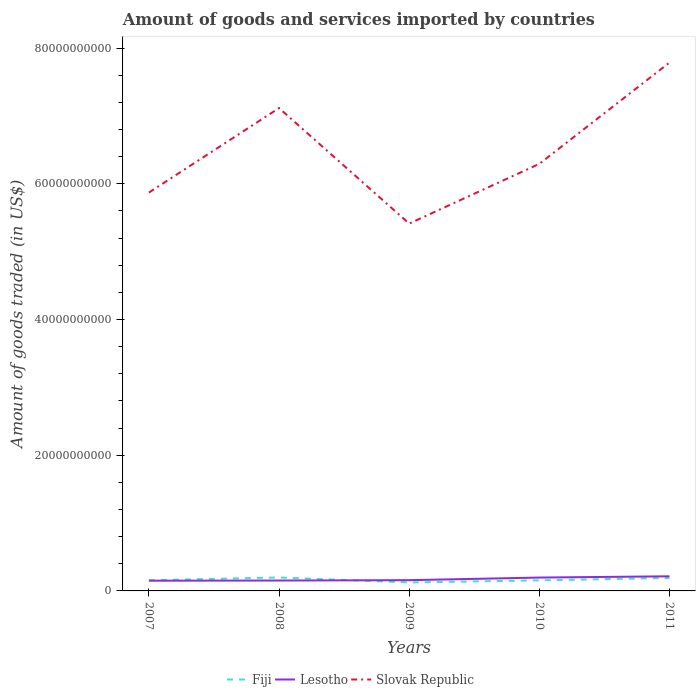How many different coloured lines are there?
Your response must be concise. 3. Does the line corresponding to Lesotho intersect with the line corresponding to Slovak Republic?
Offer a very short reply. No. Across all years, what is the maximum total amount of goods and services imported in Slovak Republic?
Keep it short and to the point. 5.41e+1. In which year was the total amount of goods and services imported in Lesotho maximum?
Provide a succinct answer. 2007. What is the total total amount of goods and services imported in Fiji in the graph?
Keep it short and to the point. 4.24e+08. What is the difference between the highest and the second highest total amount of goods and services imported in Lesotho?
Give a very brief answer. 6.49e+08. What is the difference between the highest and the lowest total amount of goods and services imported in Lesotho?
Provide a succinct answer. 2. Is the total amount of goods and services imported in Lesotho strictly greater than the total amount of goods and services imported in Slovak Republic over the years?
Provide a short and direct response. Yes. Are the values on the major ticks of Y-axis written in scientific E-notation?
Make the answer very short. No. Does the graph contain any zero values?
Your answer should be compact. No. Does the graph contain grids?
Provide a short and direct response. No. How many legend labels are there?
Your response must be concise. 3. How are the legend labels stacked?
Ensure brevity in your answer.  Horizontal. What is the title of the graph?
Give a very brief answer. Amount of goods and services imported by countries. What is the label or title of the Y-axis?
Your answer should be very brief. Amount of goods traded (in US$). What is the Amount of goods traded (in US$) of Fiji in 2007?
Ensure brevity in your answer.  1.58e+09. What is the Amount of goods traded (in US$) of Lesotho in 2007?
Keep it short and to the point. 1.51e+09. What is the Amount of goods traded (in US$) of Slovak Republic in 2007?
Ensure brevity in your answer.  5.87e+1. What is the Amount of goods traded (in US$) of Fiji in 2008?
Offer a terse response. 1.98e+09. What is the Amount of goods traded (in US$) in Lesotho in 2008?
Ensure brevity in your answer.  1.53e+09. What is the Amount of goods traded (in US$) of Slovak Republic in 2008?
Offer a very short reply. 7.12e+1. What is the Amount of goods traded (in US$) in Fiji in 2009?
Give a very brief answer. 1.25e+09. What is the Amount of goods traded (in US$) in Lesotho in 2009?
Make the answer very short. 1.58e+09. What is the Amount of goods traded (in US$) of Slovak Republic in 2009?
Offer a very short reply. 5.41e+1. What is the Amount of goods traded (in US$) of Fiji in 2010?
Provide a short and direct response. 1.56e+09. What is the Amount of goods traded (in US$) in Lesotho in 2010?
Keep it short and to the point. 1.97e+09. What is the Amount of goods traded (in US$) of Slovak Republic in 2010?
Offer a terse response. 6.29e+1. What is the Amount of goods traded (in US$) in Fiji in 2011?
Your answer should be compact. 1.91e+09. What is the Amount of goods traded (in US$) of Lesotho in 2011?
Make the answer very short. 2.16e+09. What is the Amount of goods traded (in US$) of Slovak Republic in 2011?
Give a very brief answer. 7.79e+1. Across all years, what is the maximum Amount of goods traded (in US$) of Fiji?
Provide a short and direct response. 1.98e+09. Across all years, what is the maximum Amount of goods traded (in US$) in Lesotho?
Offer a terse response. 2.16e+09. Across all years, what is the maximum Amount of goods traded (in US$) in Slovak Republic?
Ensure brevity in your answer.  7.79e+1. Across all years, what is the minimum Amount of goods traded (in US$) of Fiji?
Offer a terse response. 1.25e+09. Across all years, what is the minimum Amount of goods traded (in US$) of Lesotho?
Keep it short and to the point. 1.51e+09. Across all years, what is the minimum Amount of goods traded (in US$) of Slovak Republic?
Ensure brevity in your answer.  5.41e+1. What is the total Amount of goods traded (in US$) in Fiji in the graph?
Offer a terse response. 8.28e+09. What is the total Amount of goods traded (in US$) of Lesotho in the graph?
Provide a succinct answer. 8.75e+09. What is the total Amount of goods traded (in US$) of Slovak Republic in the graph?
Your answer should be compact. 3.25e+11. What is the difference between the Amount of goods traded (in US$) in Fiji in 2007 and that in 2008?
Make the answer very short. -4.08e+08. What is the difference between the Amount of goods traded (in US$) of Lesotho in 2007 and that in 2008?
Give a very brief answer. -2.55e+07. What is the difference between the Amount of goods traded (in US$) of Slovak Republic in 2007 and that in 2008?
Give a very brief answer. -1.25e+1. What is the difference between the Amount of goods traded (in US$) in Fiji in 2007 and that in 2009?
Make the answer very short. 3.30e+08. What is the difference between the Amount of goods traded (in US$) in Lesotho in 2007 and that in 2009?
Your answer should be very brief. -7.72e+07. What is the difference between the Amount of goods traded (in US$) of Slovak Republic in 2007 and that in 2009?
Give a very brief answer. 4.57e+09. What is the difference between the Amount of goods traded (in US$) of Fiji in 2007 and that in 2010?
Offer a terse response. 1.55e+07. What is the difference between the Amount of goods traded (in US$) of Lesotho in 2007 and that in 2010?
Give a very brief answer. -4.63e+08. What is the difference between the Amount of goods traded (in US$) in Slovak Republic in 2007 and that in 2010?
Provide a short and direct response. -4.23e+09. What is the difference between the Amount of goods traded (in US$) of Fiji in 2007 and that in 2011?
Provide a short and direct response. -3.37e+08. What is the difference between the Amount of goods traded (in US$) of Lesotho in 2007 and that in 2011?
Your response must be concise. -6.49e+08. What is the difference between the Amount of goods traded (in US$) in Slovak Republic in 2007 and that in 2011?
Offer a terse response. -1.92e+1. What is the difference between the Amount of goods traded (in US$) of Fiji in 2008 and that in 2009?
Offer a very short reply. 7.38e+08. What is the difference between the Amount of goods traded (in US$) of Lesotho in 2008 and that in 2009?
Ensure brevity in your answer.  -5.17e+07. What is the difference between the Amount of goods traded (in US$) in Slovak Republic in 2008 and that in 2009?
Offer a very short reply. 1.70e+1. What is the difference between the Amount of goods traded (in US$) of Fiji in 2008 and that in 2010?
Make the answer very short. 4.24e+08. What is the difference between the Amount of goods traded (in US$) of Lesotho in 2008 and that in 2010?
Make the answer very short. -4.37e+08. What is the difference between the Amount of goods traded (in US$) in Slovak Republic in 2008 and that in 2010?
Your answer should be compact. 8.22e+09. What is the difference between the Amount of goods traded (in US$) in Fiji in 2008 and that in 2011?
Offer a very short reply. 7.09e+07. What is the difference between the Amount of goods traded (in US$) of Lesotho in 2008 and that in 2011?
Your response must be concise. -6.24e+08. What is the difference between the Amount of goods traded (in US$) of Slovak Republic in 2008 and that in 2011?
Keep it short and to the point. -6.71e+09. What is the difference between the Amount of goods traded (in US$) of Fiji in 2009 and that in 2010?
Keep it short and to the point. -3.14e+08. What is the difference between the Amount of goods traded (in US$) in Lesotho in 2009 and that in 2010?
Make the answer very short. -3.85e+08. What is the difference between the Amount of goods traded (in US$) of Slovak Republic in 2009 and that in 2010?
Provide a succinct answer. -8.80e+09. What is the difference between the Amount of goods traded (in US$) in Fiji in 2009 and that in 2011?
Your answer should be very brief. -6.67e+08. What is the difference between the Amount of goods traded (in US$) of Lesotho in 2009 and that in 2011?
Offer a very short reply. -5.72e+08. What is the difference between the Amount of goods traded (in US$) in Slovak Republic in 2009 and that in 2011?
Make the answer very short. -2.37e+1. What is the difference between the Amount of goods traded (in US$) in Fiji in 2010 and that in 2011?
Keep it short and to the point. -3.53e+08. What is the difference between the Amount of goods traded (in US$) of Lesotho in 2010 and that in 2011?
Your answer should be compact. -1.87e+08. What is the difference between the Amount of goods traded (in US$) in Slovak Republic in 2010 and that in 2011?
Ensure brevity in your answer.  -1.49e+1. What is the difference between the Amount of goods traded (in US$) in Fiji in 2007 and the Amount of goods traded (in US$) in Lesotho in 2008?
Offer a terse response. 4.39e+07. What is the difference between the Amount of goods traded (in US$) in Fiji in 2007 and the Amount of goods traded (in US$) in Slovak Republic in 2008?
Give a very brief answer. -6.96e+1. What is the difference between the Amount of goods traded (in US$) in Lesotho in 2007 and the Amount of goods traded (in US$) in Slovak Republic in 2008?
Your answer should be compact. -6.97e+1. What is the difference between the Amount of goods traded (in US$) of Fiji in 2007 and the Amount of goods traded (in US$) of Lesotho in 2009?
Ensure brevity in your answer.  -7.79e+06. What is the difference between the Amount of goods traded (in US$) of Fiji in 2007 and the Amount of goods traded (in US$) of Slovak Republic in 2009?
Ensure brevity in your answer.  -5.26e+1. What is the difference between the Amount of goods traded (in US$) in Lesotho in 2007 and the Amount of goods traded (in US$) in Slovak Republic in 2009?
Offer a very short reply. -5.26e+1. What is the difference between the Amount of goods traded (in US$) in Fiji in 2007 and the Amount of goods traded (in US$) in Lesotho in 2010?
Keep it short and to the point. -3.93e+08. What is the difference between the Amount of goods traded (in US$) in Fiji in 2007 and the Amount of goods traded (in US$) in Slovak Republic in 2010?
Offer a terse response. -6.14e+1. What is the difference between the Amount of goods traded (in US$) of Lesotho in 2007 and the Amount of goods traded (in US$) of Slovak Republic in 2010?
Offer a terse response. -6.14e+1. What is the difference between the Amount of goods traded (in US$) in Fiji in 2007 and the Amount of goods traded (in US$) in Lesotho in 2011?
Your answer should be compact. -5.80e+08. What is the difference between the Amount of goods traded (in US$) in Fiji in 2007 and the Amount of goods traded (in US$) in Slovak Republic in 2011?
Ensure brevity in your answer.  -7.63e+1. What is the difference between the Amount of goods traded (in US$) in Lesotho in 2007 and the Amount of goods traded (in US$) in Slovak Republic in 2011?
Give a very brief answer. -7.64e+1. What is the difference between the Amount of goods traded (in US$) of Fiji in 2008 and the Amount of goods traded (in US$) of Lesotho in 2009?
Provide a succinct answer. 4.00e+08. What is the difference between the Amount of goods traded (in US$) in Fiji in 2008 and the Amount of goods traded (in US$) in Slovak Republic in 2009?
Give a very brief answer. -5.22e+1. What is the difference between the Amount of goods traded (in US$) of Lesotho in 2008 and the Amount of goods traded (in US$) of Slovak Republic in 2009?
Provide a short and direct response. -5.26e+1. What is the difference between the Amount of goods traded (in US$) in Fiji in 2008 and the Amount of goods traded (in US$) in Lesotho in 2010?
Offer a terse response. 1.49e+07. What is the difference between the Amount of goods traded (in US$) of Fiji in 2008 and the Amount of goods traded (in US$) of Slovak Republic in 2010?
Offer a very short reply. -6.10e+1. What is the difference between the Amount of goods traded (in US$) in Lesotho in 2008 and the Amount of goods traded (in US$) in Slovak Republic in 2010?
Give a very brief answer. -6.14e+1. What is the difference between the Amount of goods traded (in US$) of Fiji in 2008 and the Amount of goods traded (in US$) of Lesotho in 2011?
Make the answer very short. -1.72e+08. What is the difference between the Amount of goods traded (in US$) of Fiji in 2008 and the Amount of goods traded (in US$) of Slovak Republic in 2011?
Provide a short and direct response. -7.59e+1. What is the difference between the Amount of goods traded (in US$) of Lesotho in 2008 and the Amount of goods traded (in US$) of Slovak Republic in 2011?
Your answer should be very brief. -7.63e+1. What is the difference between the Amount of goods traded (in US$) of Fiji in 2009 and the Amount of goods traded (in US$) of Lesotho in 2010?
Provide a short and direct response. -7.23e+08. What is the difference between the Amount of goods traded (in US$) of Fiji in 2009 and the Amount of goods traded (in US$) of Slovak Republic in 2010?
Your answer should be compact. -6.17e+1. What is the difference between the Amount of goods traded (in US$) of Lesotho in 2009 and the Amount of goods traded (in US$) of Slovak Republic in 2010?
Make the answer very short. -6.14e+1. What is the difference between the Amount of goods traded (in US$) of Fiji in 2009 and the Amount of goods traded (in US$) of Lesotho in 2011?
Your response must be concise. -9.09e+08. What is the difference between the Amount of goods traded (in US$) in Fiji in 2009 and the Amount of goods traded (in US$) in Slovak Republic in 2011?
Offer a terse response. -7.66e+1. What is the difference between the Amount of goods traded (in US$) of Lesotho in 2009 and the Amount of goods traded (in US$) of Slovak Republic in 2011?
Make the answer very short. -7.63e+1. What is the difference between the Amount of goods traded (in US$) of Fiji in 2010 and the Amount of goods traded (in US$) of Lesotho in 2011?
Give a very brief answer. -5.95e+08. What is the difference between the Amount of goods traded (in US$) of Fiji in 2010 and the Amount of goods traded (in US$) of Slovak Republic in 2011?
Your answer should be compact. -7.63e+1. What is the difference between the Amount of goods traded (in US$) in Lesotho in 2010 and the Amount of goods traded (in US$) in Slovak Republic in 2011?
Your response must be concise. -7.59e+1. What is the average Amount of goods traded (in US$) in Fiji per year?
Make the answer very short. 1.66e+09. What is the average Amount of goods traded (in US$) of Lesotho per year?
Offer a terse response. 1.75e+09. What is the average Amount of goods traded (in US$) in Slovak Republic per year?
Your answer should be compact. 6.50e+1. In the year 2007, what is the difference between the Amount of goods traded (in US$) in Fiji and Amount of goods traded (in US$) in Lesotho?
Ensure brevity in your answer.  6.94e+07. In the year 2007, what is the difference between the Amount of goods traded (in US$) of Fiji and Amount of goods traded (in US$) of Slovak Republic?
Offer a terse response. -5.71e+1. In the year 2007, what is the difference between the Amount of goods traded (in US$) in Lesotho and Amount of goods traded (in US$) in Slovak Republic?
Keep it short and to the point. -5.72e+1. In the year 2008, what is the difference between the Amount of goods traded (in US$) in Fiji and Amount of goods traded (in US$) in Lesotho?
Make the answer very short. 4.52e+08. In the year 2008, what is the difference between the Amount of goods traded (in US$) in Fiji and Amount of goods traded (in US$) in Slovak Republic?
Ensure brevity in your answer.  -6.92e+1. In the year 2008, what is the difference between the Amount of goods traded (in US$) in Lesotho and Amount of goods traded (in US$) in Slovak Republic?
Provide a succinct answer. -6.96e+1. In the year 2009, what is the difference between the Amount of goods traded (in US$) in Fiji and Amount of goods traded (in US$) in Lesotho?
Your answer should be very brief. -3.37e+08. In the year 2009, what is the difference between the Amount of goods traded (in US$) in Fiji and Amount of goods traded (in US$) in Slovak Republic?
Make the answer very short. -5.29e+1. In the year 2009, what is the difference between the Amount of goods traded (in US$) in Lesotho and Amount of goods traded (in US$) in Slovak Republic?
Ensure brevity in your answer.  -5.26e+1. In the year 2010, what is the difference between the Amount of goods traded (in US$) in Fiji and Amount of goods traded (in US$) in Lesotho?
Make the answer very short. -4.09e+08. In the year 2010, what is the difference between the Amount of goods traded (in US$) in Fiji and Amount of goods traded (in US$) in Slovak Republic?
Your response must be concise. -6.14e+1. In the year 2010, what is the difference between the Amount of goods traded (in US$) of Lesotho and Amount of goods traded (in US$) of Slovak Republic?
Offer a terse response. -6.10e+1. In the year 2011, what is the difference between the Amount of goods traded (in US$) of Fiji and Amount of goods traded (in US$) of Lesotho?
Your answer should be compact. -2.43e+08. In the year 2011, what is the difference between the Amount of goods traded (in US$) of Fiji and Amount of goods traded (in US$) of Slovak Republic?
Provide a short and direct response. -7.60e+1. In the year 2011, what is the difference between the Amount of goods traded (in US$) in Lesotho and Amount of goods traded (in US$) in Slovak Republic?
Provide a succinct answer. -7.57e+1. What is the ratio of the Amount of goods traded (in US$) of Fiji in 2007 to that in 2008?
Provide a short and direct response. 0.79. What is the ratio of the Amount of goods traded (in US$) in Lesotho in 2007 to that in 2008?
Make the answer very short. 0.98. What is the ratio of the Amount of goods traded (in US$) of Slovak Republic in 2007 to that in 2008?
Give a very brief answer. 0.82. What is the ratio of the Amount of goods traded (in US$) of Fiji in 2007 to that in 2009?
Your answer should be very brief. 1.26. What is the ratio of the Amount of goods traded (in US$) in Lesotho in 2007 to that in 2009?
Keep it short and to the point. 0.95. What is the ratio of the Amount of goods traded (in US$) in Slovak Republic in 2007 to that in 2009?
Ensure brevity in your answer.  1.08. What is the ratio of the Amount of goods traded (in US$) in Fiji in 2007 to that in 2010?
Provide a short and direct response. 1.01. What is the ratio of the Amount of goods traded (in US$) of Lesotho in 2007 to that in 2010?
Your answer should be compact. 0.77. What is the ratio of the Amount of goods traded (in US$) in Slovak Republic in 2007 to that in 2010?
Offer a very short reply. 0.93. What is the ratio of the Amount of goods traded (in US$) in Fiji in 2007 to that in 2011?
Your answer should be compact. 0.82. What is the ratio of the Amount of goods traded (in US$) of Lesotho in 2007 to that in 2011?
Your answer should be compact. 0.7. What is the ratio of the Amount of goods traded (in US$) of Slovak Republic in 2007 to that in 2011?
Offer a terse response. 0.75. What is the ratio of the Amount of goods traded (in US$) in Fiji in 2008 to that in 2009?
Your answer should be compact. 1.59. What is the ratio of the Amount of goods traded (in US$) of Lesotho in 2008 to that in 2009?
Ensure brevity in your answer.  0.97. What is the ratio of the Amount of goods traded (in US$) in Slovak Republic in 2008 to that in 2009?
Keep it short and to the point. 1.31. What is the ratio of the Amount of goods traded (in US$) of Fiji in 2008 to that in 2010?
Keep it short and to the point. 1.27. What is the ratio of the Amount of goods traded (in US$) in Lesotho in 2008 to that in 2010?
Make the answer very short. 0.78. What is the ratio of the Amount of goods traded (in US$) of Slovak Republic in 2008 to that in 2010?
Provide a succinct answer. 1.13. What is the ratio of the Amount of goods traded (in US$) of Fiji in 2008 to that in 2011?
Provide a succinct answer. 1.04. What is the ratio of the Amount of goods traded (in US$) of Lesotho in 2008 to that in 2011?
Make the answer very short. 0.71. What is the ratio of the Amount of goods traded (in US$) of Slovak Republic in 2008 to that in 2011?
Your response must be concise. 0.91. What is the ratio of the Amount of goods traded (in US$) in Fiji in 2009 to that in 2010?
Offer a very short reply. 0.8. What is the ratio of the Amount of goods traded (in US$) of Lesotho in 2009 to that in 2010?
Keep it short and to the point. 0.8. What is the ratio of the Amount of goods traded (in US$) of Slovak Republic in 2009 to that in 2010?
Provide a succinct answer. 0.86. What is the ratio of the Amount of goods traded (in US$) of Fiji in 2009 to that in 2011?
Give a very brief answer. 0.65. What is the ratio of the Amount of goods traded (in US$) in Lesotho in 2009 to that in 2011?
Your response must be concise. 0.73. What is the ratio of the Amount of goods traded (in US$) in Slovak Republic in 2009 to that in 2011?
Your answer should be very brief. 0.7. What is the ratio of the Amount of goods traded (in US$) of Fiji in 2010 to that in 2011?
Give a very brief answer. 0.82. What is the ratio of the Amount of goods traded (in US$) in Lesotho in 2010 to that in 2011?
Make the answer very short. 0.91. What is the ratio of the Amount of goods traded (in US$) of Slovak Republic in 2010 to that in 2011?
Make the answer very short. 0.81. What is the difference between the highest and the second highest Amount of goods traded (in US$) in Fiji?
Offer a very short reply. 7.09e+07. What is the difference between the highest and the second highest Amount of goods traded (in US$) of Lesotho?
Keep it short and to the point. 1.87e+08. What is the difference between the highest and the second highest Amount of goods traded (in US$) in Slovak Republic?
Ensure brevity in your answer.  6.71e+09. What is the difference between the highest and the lowest Amount of goods traded (in US$) in Fiji?
Provide a short and direct response. 7.38e+08. What is the difference between the highest and the lowest Amount of goods traded (in US$) in Lesotho?
Keep it short and to the point. 6.49e+08. What is the difference between the highest and the lowest Amount of goods traded (in US$) of Slovak Republic?
Make the answer very short. 2.37e+1. 